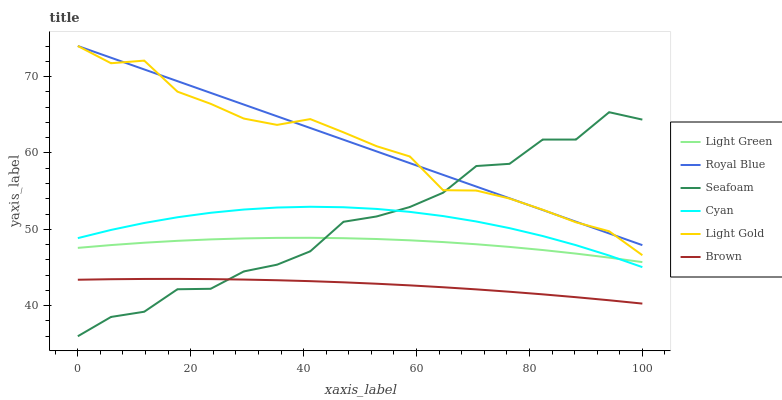Does Brown have the minimum area under the curve?
Answer yes or no. Yes. Does Royal Blue have the maximum area under the curve?
Answer yes or no. Yes. Does Seafoam have the minimum area under the curve?
Answer yes or no. No. Does Seafoam have the maximum area under the curve?
Answer yes or no. No. Is Royal Blue the smoothest?
Answer yes or no. Yes. Is Seafoam the roughest?
Answer yes or no. Yes. Is Seafoam the smoothest?
Answer yes or no. No. Is Royal Blue the roughest?
Answer yes or no. No. Does Royal Blue have the lowest value?
Answer yes or no. No. Does Light Gold have the highest value?
Answer yes or no. Yes. Does Seafoam have the highest value?
Answer yes or no. No. Is Brown less than Cyan?
Answer yes or no. Yes. Is Light Gold greater than Light Green?
Answer yes or no. Yes. Does Brown intersect Seafoam?
Answer yes or no. Yes. Is Brown less than Seafoam?
Answer yes or no. No. Is Brown greater than Seafoam?
Answer yes or no. No. Does Brown intersect Cyan?
Answer yes or no. No. 